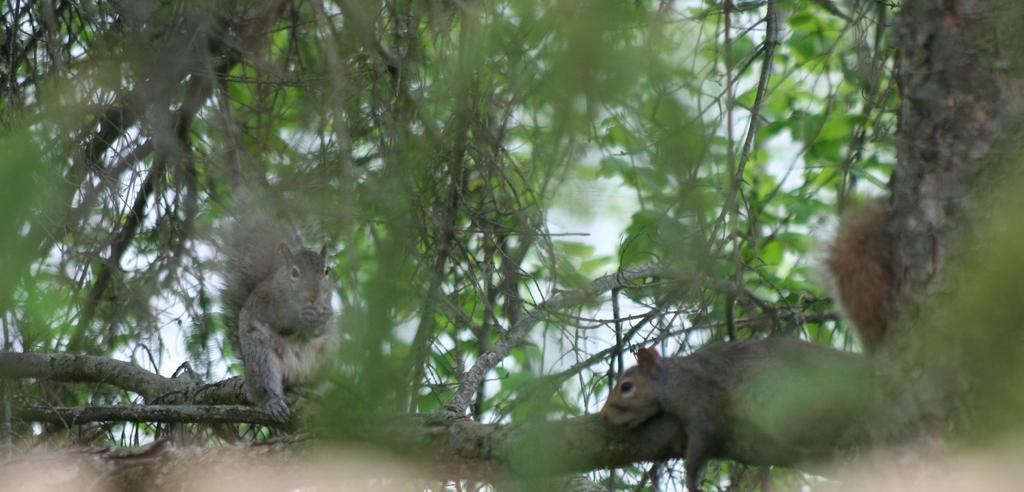Please provide a concise description of this image. On this wooden branch there are squirrels. This is tree. 